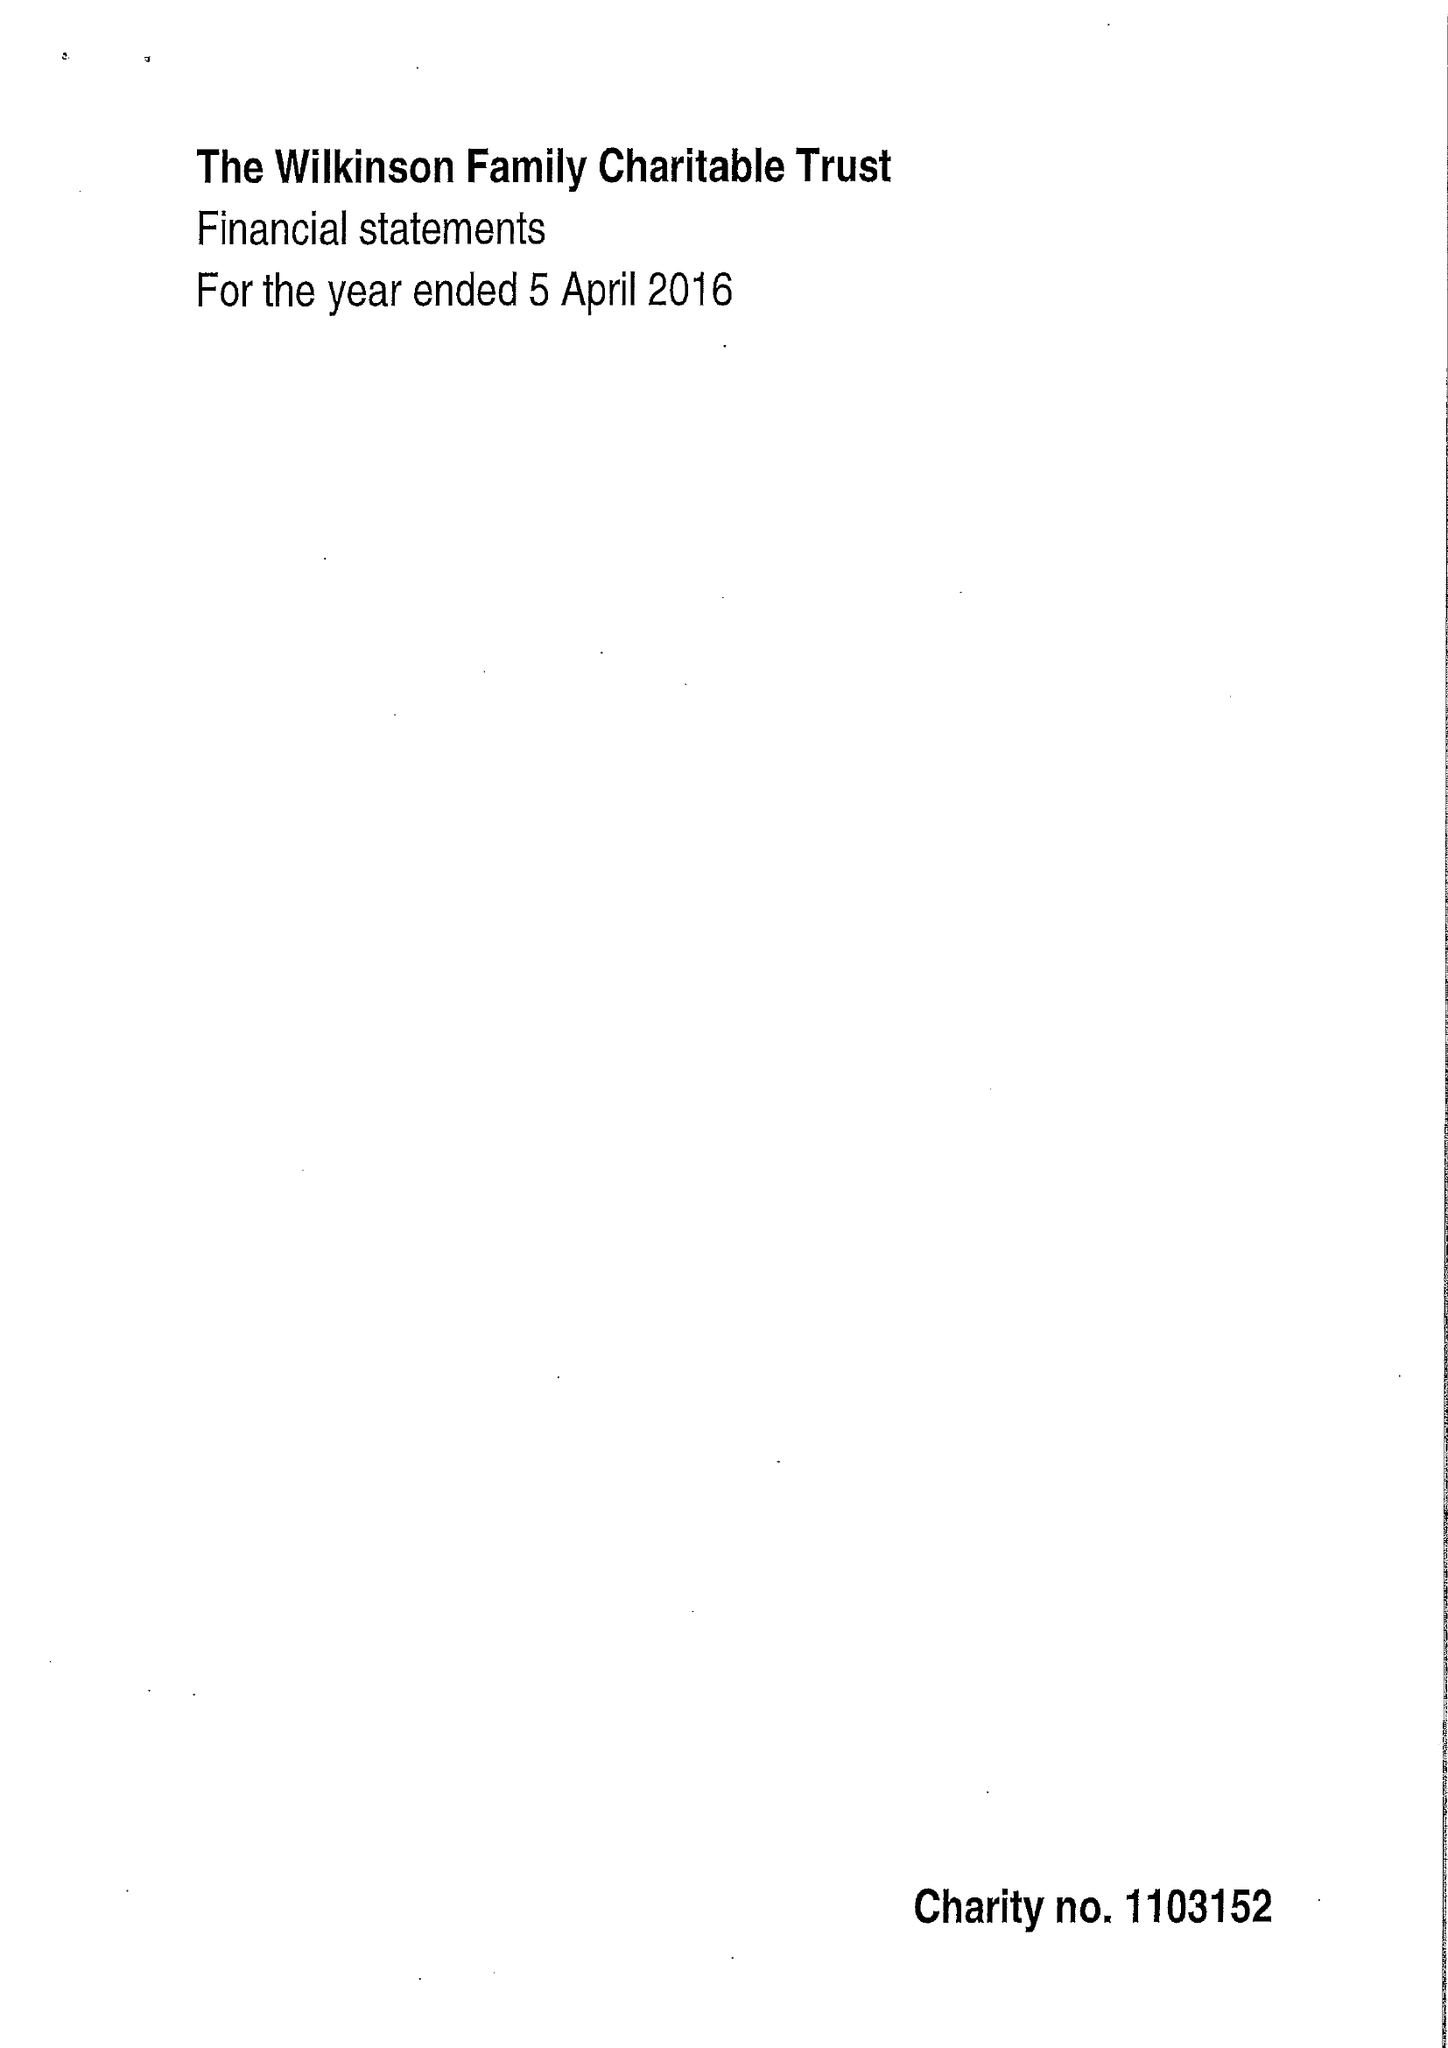What is the value for the charity_name?
Answer the question using a single word or phrase. Wilkinson Family Charitable Trust 